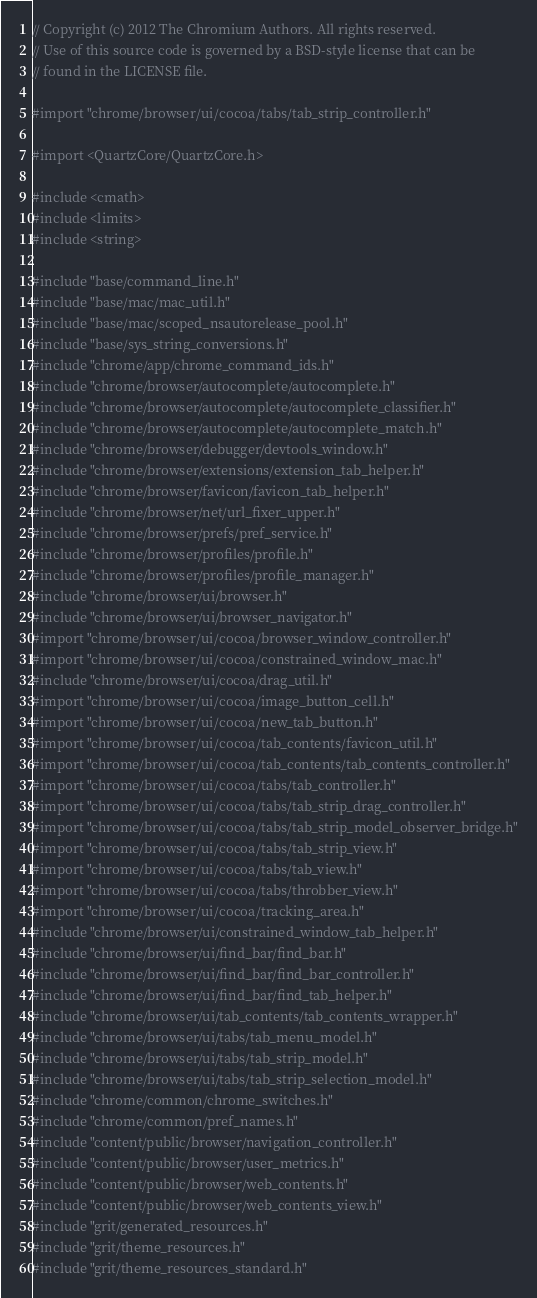<code> <loc_0><loc_0><loc_500><loc_500><_ObjectiveC_>// Copyright (c) 2012 The Chromium Authors. All rights reserved.
// Use of this source code is governed by a BSD-style license that can be
// found in the LICENSE file.

#import "chrome/browser/ui/cocoa/tabs/tab_strip_controller.h"

#import <QuartzCore/QuartzCore.h>

#include <cmath>
#include <limits>
#include <string>

#include "base/command_line.h"
#include "base/mac/mac_util.h"
#include "base/mac/scoped_nsautorelease_pool.h"
#include "base/sys_string_conversions.h"
#include "chrome/app/chrome_command_ids.h"
#include "chrome/browser/autocomplete/autocomplete.h"
#include "chrome/browser/autocomplete/autocomplete_classifier.h"
#include "chrome/browser/autocomplete/autocomplete_match.h"
#include "chrome/browser/debugger/devtools_window.h"
#include "chrome/browser/extensions/extension_tab_helper.h"
#include "chrome/browser/favicon/favicon_tab_helper.h"
#include "chrome/browser/net/url_fixer_upper.h"
#include "chrome/browser/prefs/pref_service.h"
#include "chrome/browser/profiles/profile.h"
#include "chrome/browser/profiles/profile_manager.h"
#include "chrome/browser/ui/browser.h"
#include "chrome/browser/ui/browser_navigator.h"
#import "chrome/browser/ui/cocoa/browser_window_controller.h"
#import "chrome/browser/ui/cocoa/constrained_window_mac.h"
#include "chrome/browser/ui/cocoa/drag_util.h"
#import "chrome/browser/ui/cocoa/image_button_cell.h"
#import "chrome/browser/ui/cocoa/new_tab_button.h"
#import "chrome/browser/ui/cocoa/tab_contents/favicon_util.h"
#import "chrome/browser/ui/cocoa/tab_contents/tab_contents_controller.h"
#import "chrome/browser/ui/cocoa/tabs/tab_controller.h"
#import "chrome/browser/ui/cocoa/tabs/tab_strip_drag_controller.h"
#import "chrome/browser/ui/cocoa/tabs/tab_strip_model_observer_bridge.h"
#import "chrome/browser/ui/cocoa/tabs/tab_strip_view.h"
#import "chrome/browser/ui/cocoa/tabs/tab_view.h"
#import "chrome/browser/ui/cocoa/tabs/throbber_view.h"
#import "chrome/browser/ui/cocoa/tracking_area.h"
#include "chrome/browser/ui/constrained_window_tab_helper.h"
#include "chrome/browser/ui/find_bar/find_bar.h"
#include "chrome/browser/ui/find_bar/find_bar_controller.h"
#include "chrome/browser/ui/find_bar/find_tab_helper.h"
#include "chrome/browser/ui/tab_contents/tab_contents_wrapper.h"
#include "chrome/browser/ui/tabs/tab_menu_model.h"
#include "chrome/browser/ui/tabs/tab_strip_model.h"
#include "chrome/browser/ui/tabs/tab_strip_selection_model.h"
#include "chrome/common/chrome_switches.h"
#include "chrome/common/pref_names.h"
#include "content/public/browser/navigation_controller.h"
#include "content/public/browser/user_metrics.h"
#include "content/public/browser/web_contents.h"
#include "content/public/browser/web_contents_view.h"
#include "grit/generated_resources.h"
#include "grit/theme_resources.h"
#include "grit/theme_resources_standard.h"</code> 